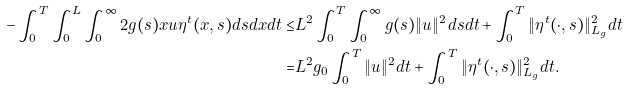Convert formula to latex. <formula><loc_0><loc_0><loc_500><loc_500>- \int _ { 0 } ^ { T } \int _ { 0 } ^ { L } \int _ { 0 } ^ { \infty } 2 g ( s ) x u \eta ^ { t } ( x , s ) d s d x d t \leq & L ^ { 2 } \int _ { 0 } ^ { T } \int _ { 0 } ^ { \infty } g ( s ) \| u \| ^ { 2 } d s d t + \int _ { 0 } ^ { T } \| \eta ^ { t } ( \cdot , s ) \| ^ { 2 } _ { L _ { g } } d t \\ = & L ^ { 2 } g _ { 0 } \int _ { 0 } ^ { T } \| u \| ^ { 2 } d t + \int _ { 0 } ^ { T } \| \eta ^ { t } ( \cdot , s ) \| ^ { 2 } _ { L _ { g } } d t .</formula> 